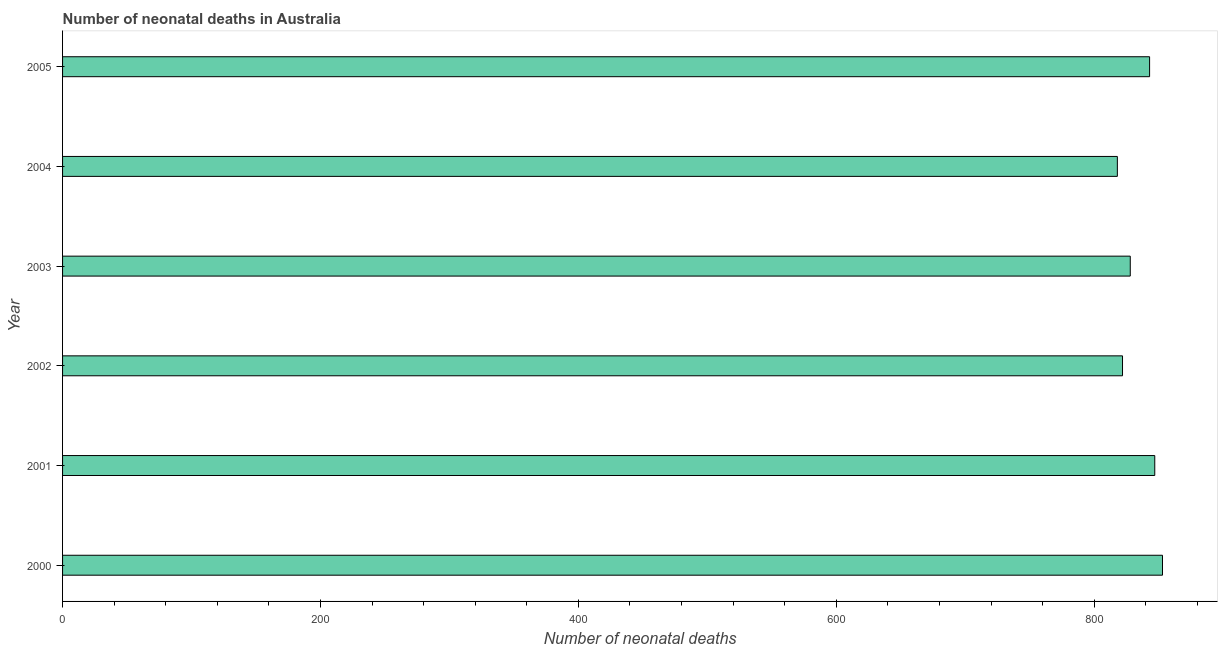Does the graph contain any zero values?
Your response must be concise. No. What is the title of the graph?
Your answer should be very brief. Number of neonatal deaths in Australia. What is the label or title of the X-axis?
Offer a terse response. Number of neonatal deaths. What is the label or title of the Y-axis?
Provide a succinct answer. Year. What is the number of neonatal deaths in 2002?
Offer a very short reply. 822. Across all years, what is the maximum number of neonatal deaths?
Offer a terse response. 853. Across all years, what is the minimum number of neonatal deaths?
Your answer should be compact. 818. In which year was the number of neonatal deaths maximum?
Make the answer very short. 2000. What is the sum of the number of neonatal deaths?
Offer a terse response. 5011. What is the average number of neonatal deaths per year?
Your answer should be compact. 835. What is the median number of neonatal deaths?
Give a very brief answer. 835.5. Do a majority of the years between 2002 and 2003 (inclusive) have number of neonatal deaths greater than 120 ?
Ensure brevity in your answer.  Yes. Is the sum of the number of neonatal deaths in 2000 and 2003 greater than the maximum number of neonatal deaths across all years?
Your response must be concise. Yes. Are all the bars in the graph horizontal?
Offer a very short reply. Yes. How many years are there in the graph?
Provide a succinct answer. 6. Are the values on the major ticks of X-axis written in scientific E-notation?
Your answer should be very brief. No. What is the Number of neonatal deaths in 2000?
Make the answer very short. 853. What is the Number of neonatal deaths in 2001?
Your response must be concise. 847. What is the Number of neonatal deaths in 2002?
Ensure brevity in your answer.  822. What is the Number of neonatal deaths of 2003?
Provide a short and direct response. 828. What is the Number of neonatal deaths of 2004?
Offer a terse response. 818. What is the Number of neonatal deaths in 2005?
Your response must be concise. 843. What is the difference between the Number of neonatal deaths in 2000 and 2001?
Keep it short and to the point. 6. What is the difference between the Number of neonatal deaths in 2000 and 2002?
Keep it short and to the point. 31. What is the difference between the Number of neonatal deaths in 2000 and 2003?
Offer a terse response. 25. What is the difference between the Number of neonatal deaths in 2000 and 2005?
Your answer should be very brief. 10. What is the difference between the Number of neonatal deaths in 2001 and 2002?
Provide a short and direct response. 25. What is the difference between the Number of neonatal deaths in 2001 and 2003?
Offer a terse response. 19. What is the difference between the Number of neonatal deaths in 2001 and 2004?
Provide a short and direct response. 29. What is the difference between the Number of neonatal deaths in 2001 and 2005?
Ensure brevity in your answer.  4. What is the difference between the Number of neonatal deaths in 2002 and 2004?
Offer a terse response. 4. What is the difference between the Number of neonatal deaths in 2003 and 2005?
Provide a succinct answer. -15. What is the ratio of the Number of neonatal deaths in 2000 to that in 2002?
Offer a very short reply. 1.04. What is the ratio of the Number of neonatal deaths in 2000 to that in 2003?
Provide a succinct answer. 1.03. What is the ratio of the Number of neonatal deaths in 2000 to that in 2004?
Ensure brevity in your answer.  1.04. What is the ratio of the Number of neonatal deaths in 2001 to that in 2004?
Keep it short and to the point. 1.03. What is the ratio of the Number of neonatal deaths in 2002 to that in 2003?
Your response must be concise. 0.99. What is the ratio of the Number of neonatal deaths in 2002 to that in 2005?
Make the answer very short. 0.97. What is the ratio of the Number of neonatal deaths in 2003 to that in 2004?
Your answer should be compact. 1.01. 